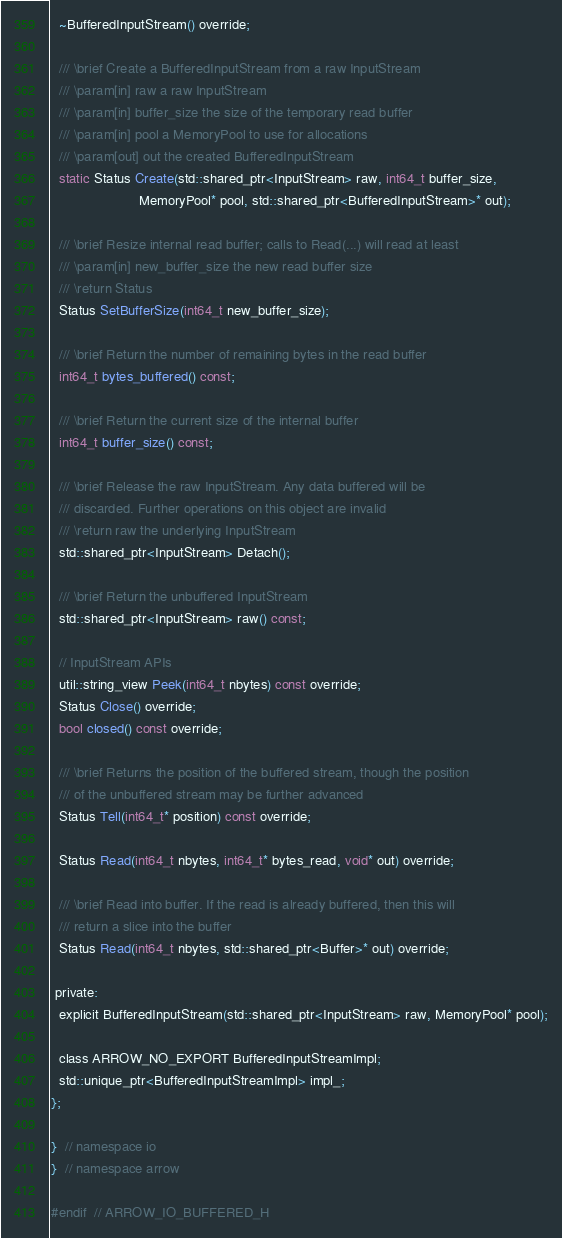Convert code to text. <code><loc_0><loc_0><loc_500><loc_500><_C_>  ~BufferedInputStream() override;

  /// \brief Create a BufferedInputStream from a raw InputStream
  /// \param[in] raw a raw InputStream
  /// \param[in] buffer_size the size of the temporary read buffer
  /// \param[in] pool a MemoryPool to use for allocations
  /// \param[out] out the created BufferedInputStream
  static Status Create(std::shared_ptr<InputStream> raw, int64_t buffer_size,
                       MemoryPool* pool, std::shared_ptr<BufferedInputStream>* out);

  /// \brief Resize internal read buffer; calls to Read(...) will read at least
  /// \param[in] new_buffer_size the new read buffer size
  /// \return Status
  Status SetBufferSize(int64_t new_buffer_size);

  /// \brief Return the number of remaining bytes in the read buffer
  int64_t bytes_buffered() const;

  /// \brief Return the current size of the internal buffer
  int64_t buffer_size() const;

  /// \brief Release the raw InputStream. Any data buffered will be
  /// discarded. Further operations on this object are invalid
  /// \return raw the underlying InputStream
  std::shared_ptr<InputStream> Detach();

  /// \brief Return the unbuffered InputStream
  std::shared_ptr<InputStream> raw() const;

  // InputStream APIs
  util::string_view Peek(int64_t nbytes) const override;
  Status Close() override;
  bool closed() const override;

  /// \brief Returns the position of the buffered stream, though the position
  /// of the unbuffered stream may be further advanced
  Status Tell(int64_t* position) const override;

  Status Read(int64_t nbytes, int64_t* bytes_read, void* out) override;

  /// \brief Read into buffer. If the read is already buffered, then this will
  /// return a slice into the buffer
  Status Read(int64_t nbytes, std::shared_ptr<Buffer>* out) override;

 private:
  explicit BufferedInputStream(std::shared_ptr<InputStream> raw, MemoryPool* pool);

  class ARROW_NO_EXPORT BufferedInputStreamImpl;
  std::unique_ptr<BufferedInputStreamImpl> impl_;
};

}  // namespace io
}  // namespace arrow

#endif  // ARROW_IO_BUFFERED_H
</code> 